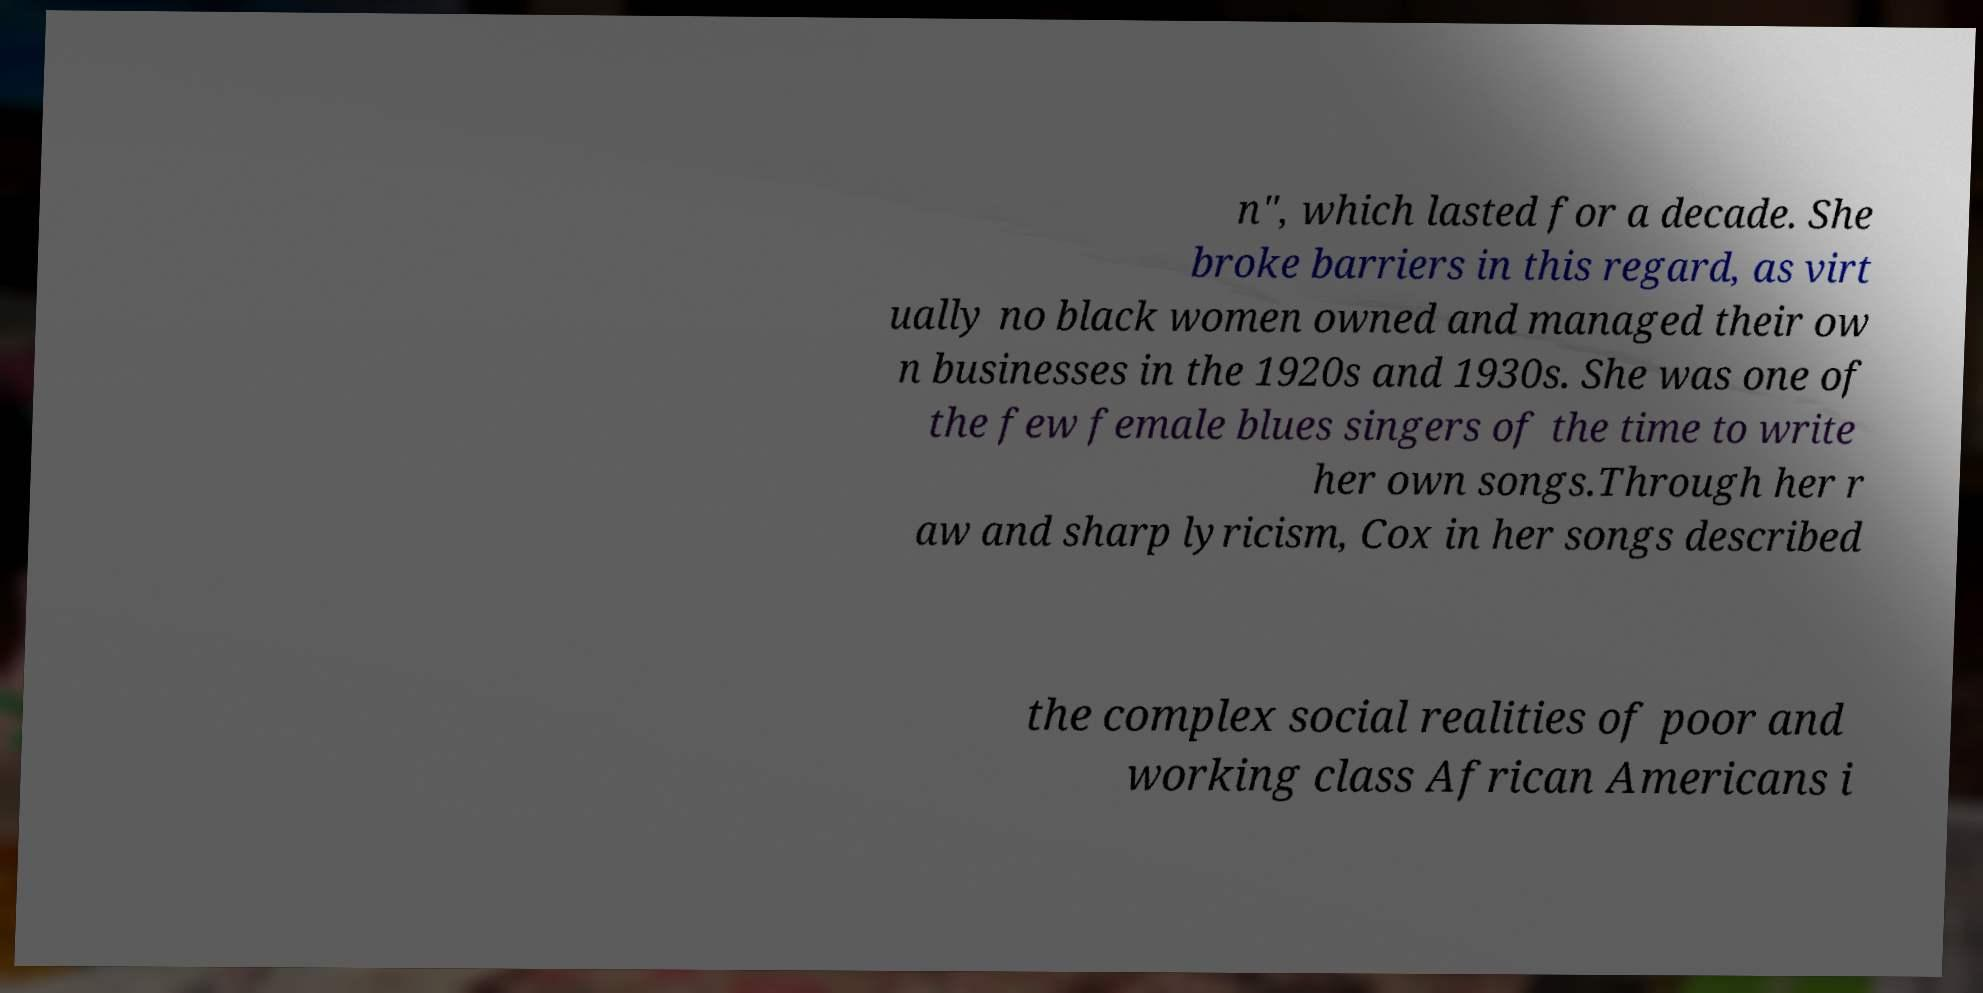I need the written content from this picture converted into text. Can you do that? n", which lasted for a decade. She broke barriers in this regard, as virt ually no black women owned and managed their ow n businesses in the 1920s and 1930s. She was one of the few female blues singers of the time to write her own songs.Through her r aw and sharp lyricism, Cox in her songs described the complex social realities of poor and working class African Americans i 